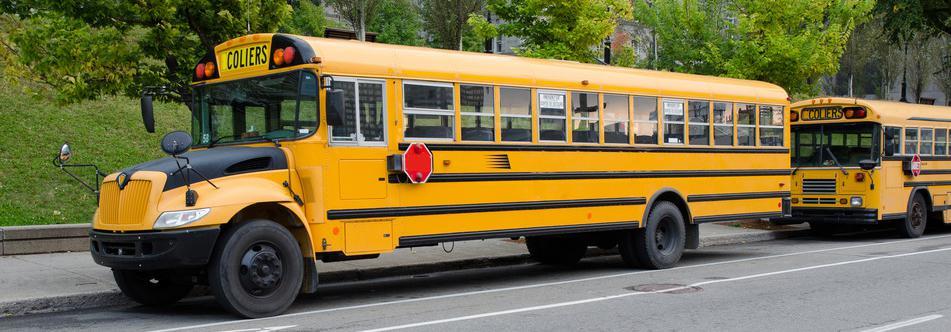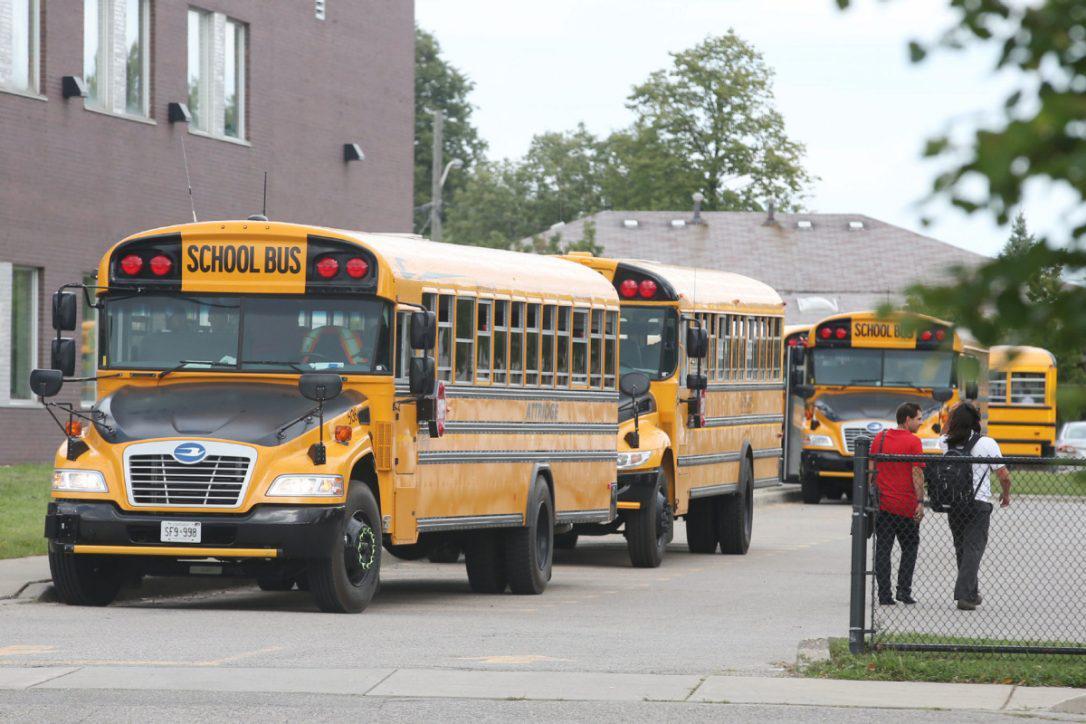The first image is the image on the left, the second image is the image on the right. Analyze the images presented: Is the assertion "A bus has its passenger door open." valid? Answer yes or no. No. The first image is the image on the left, the second image is the image on the right. Analyze the images presented: Is the assertion "In at least one image there is a short bus facing both right and forward." valid? Answer yes or no. No. 